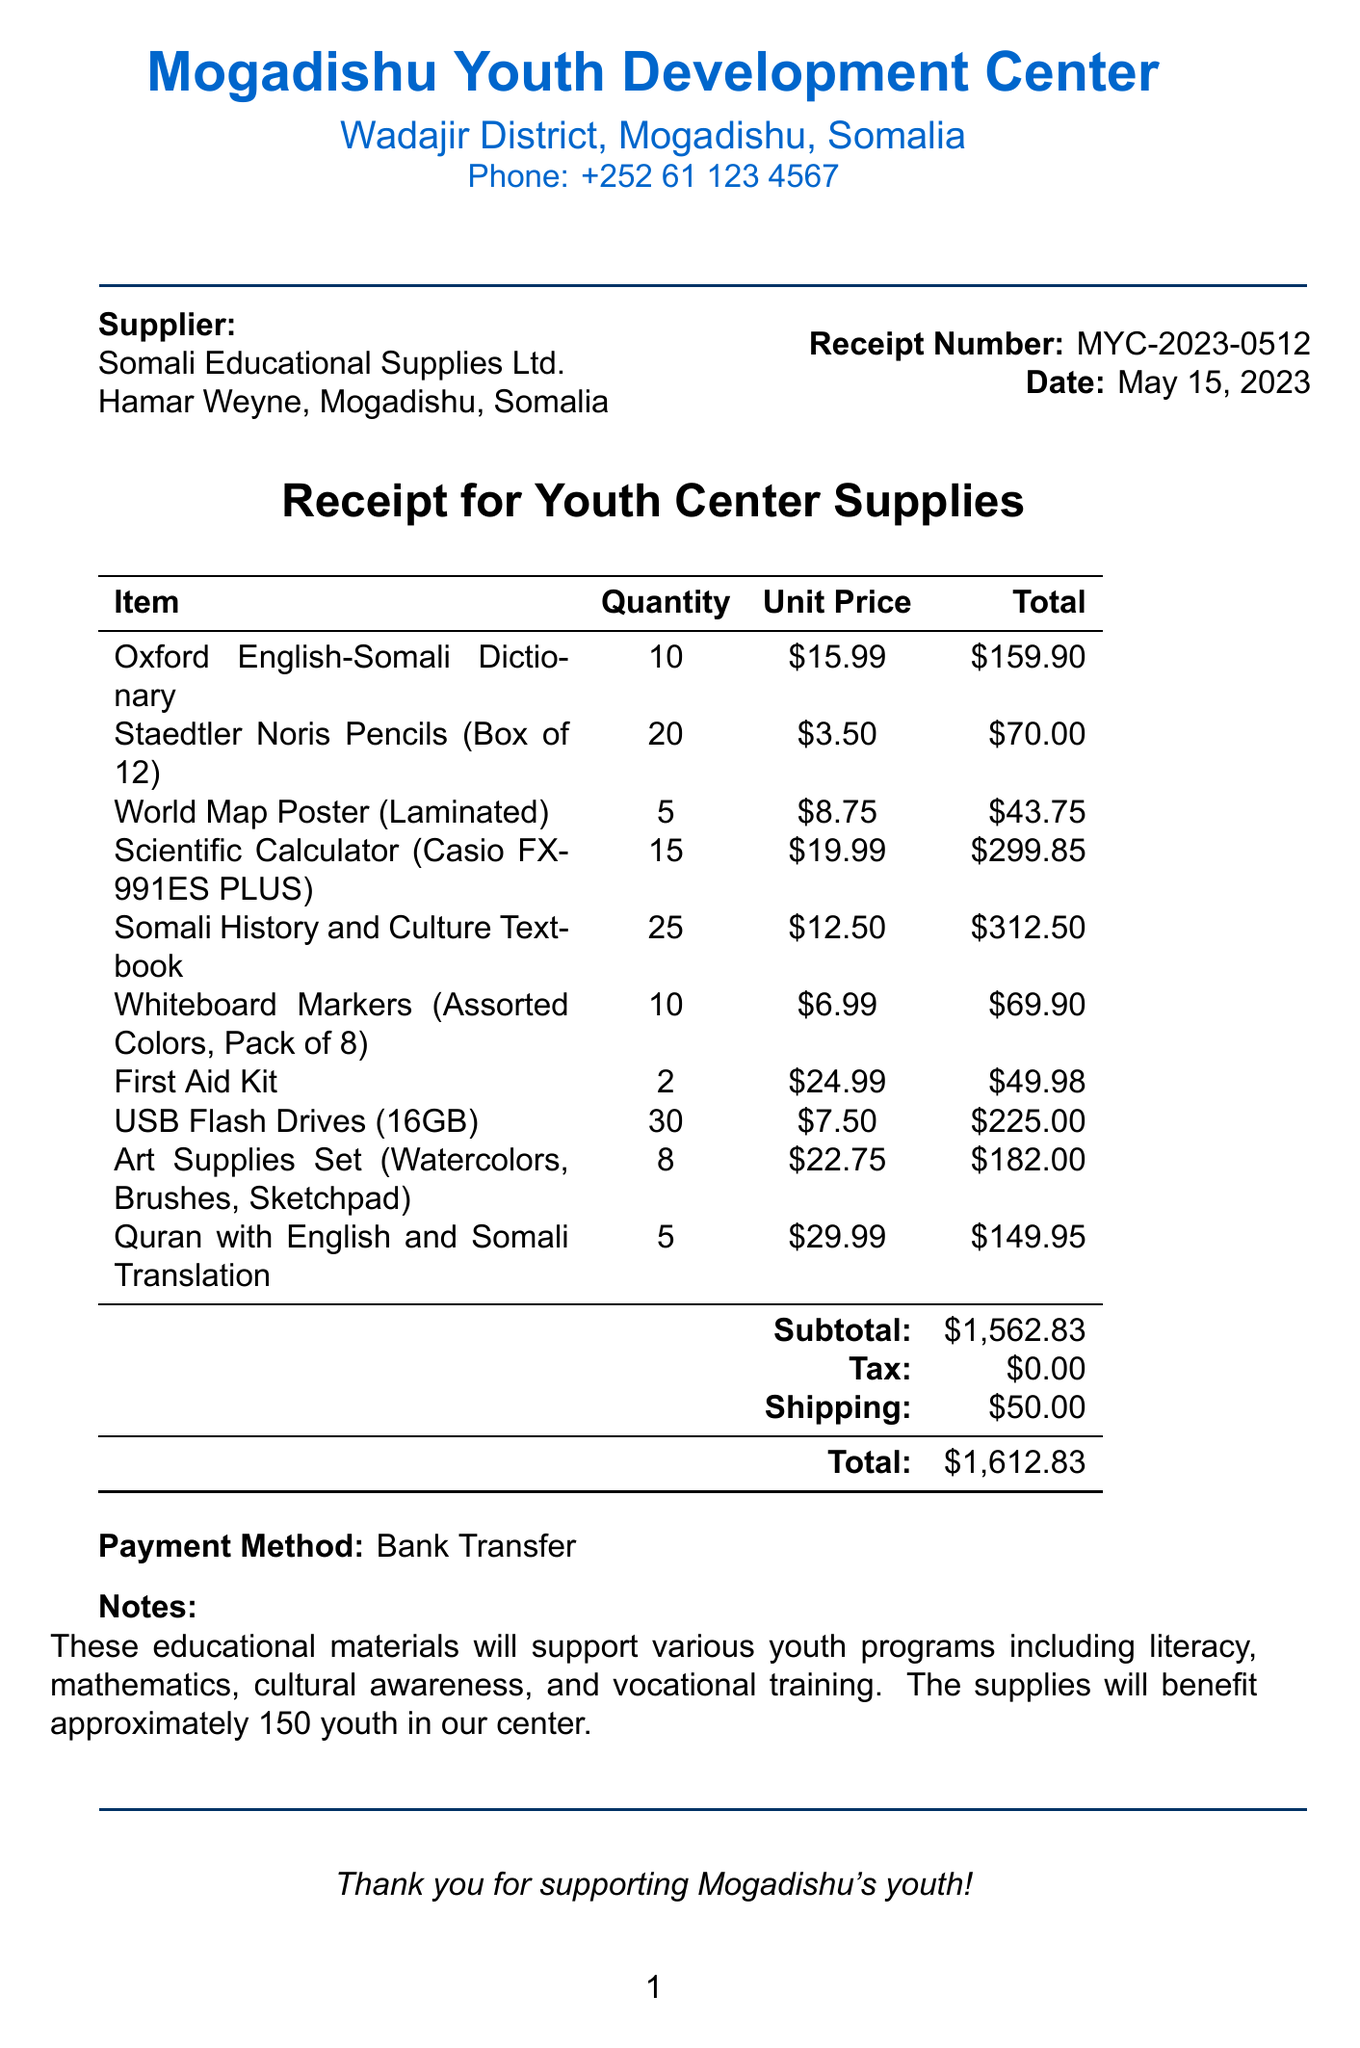What is the organization name? The organization issuing the receipt is the Mogadishu Youth Development Center.
Answer: Mogadishu Youth Development Center What is the address of the supplier? The address for Somali Educational Supplies Ltd. is mentioned in the document as Hamar Weyne, Mogadishu, Somalia.
Answer: Hamar Weyne, Mogadishu, Somalia How many Scientific Calculators were purchased? The receipt shows a quantity of 15 for the Scientific Calculator (Casio FX-991ES PLUS).
Answer: 15 What is the total amount spent? The total amount listed at the end of the receipt is calculated as $1,612.83.
Answer: $1,612.83 What date was the receipt issued? The document specifies that the receipt date is May 15, 2023.
Answer: May 15, 2023 What type of payment was used? The payment method indicated in the receipt was Bank Transfer.
Answer: Bank Transfer How many USB Flash Drives were ordered? The document indicates that 30 USB Flash Drives (16GB) were ordered.
Answer: 30 What support will these materials provide? The educational materials will support youth programs including literacy and mathematics.
Answer: Literacy, mathematics, cultural awareness, and vocational training How many youth will benefit from the supplies? The notes on the receipt state that approximately 150 youth will benefit.
Answer: 150 